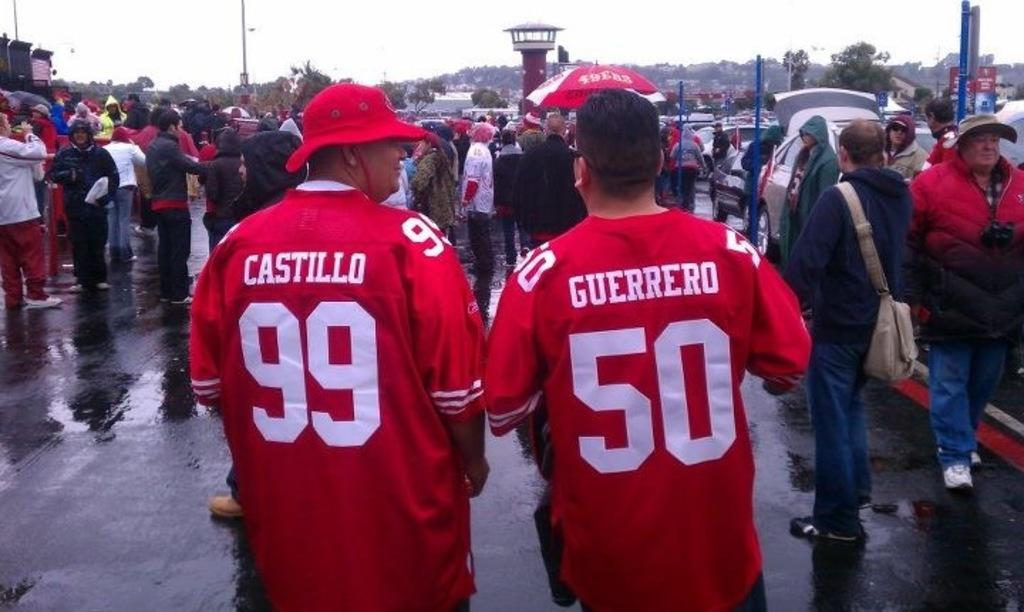What is the name of 99?
Your response must be concise. Castillo. What number is on the mans red jersey on the right?
Your answer should be very brief. 50. 